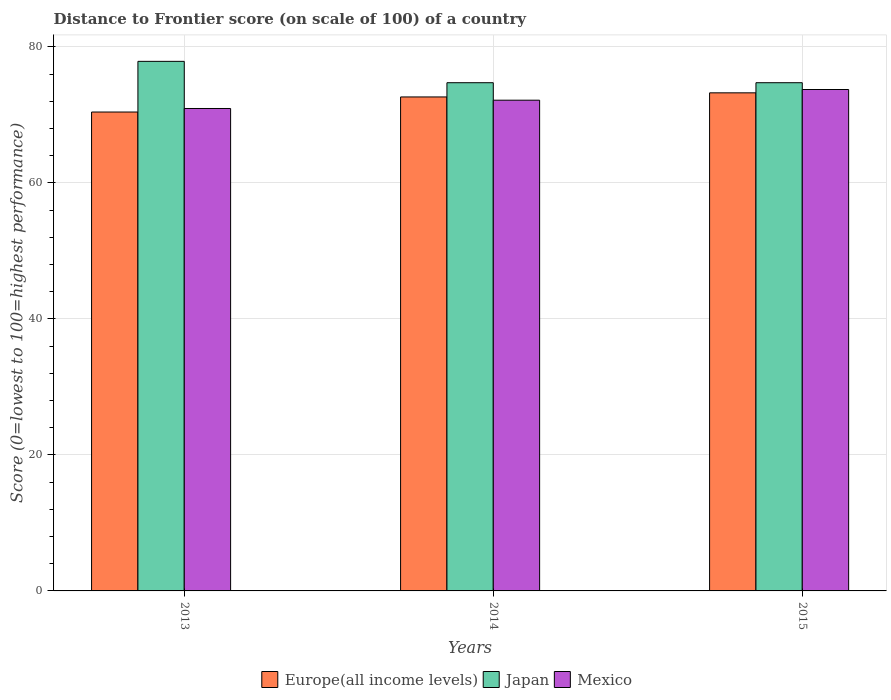How many groups of bars are there?
Keep it short and to the point. 3. Are the number of bars per tick equal to the number of legend labels?
Offer a very short reply. Yes. How many bars are there on the 1st tick from the left?
Your response must be concise. 3. How many bars are there on the 2nd tick from the right?
Make the answer very short. 3. What is the label of the 2nd group of bars from the left?
Offer a very short reply. 2014. In how many cases, is the number of bars for a given year not equal to the number of legend labels?
Offer a terse response. 0. What is the distance to frontier score of in Japan in 2013?
Give a very brief answer. 77.86. Across all years, what is the maximum distance to frontier score of in Europe(all income levels)?
Your answer should be compact. 73.23. Across all years, what is the minimum distance to frontier score of in Japan?
Ensure brevity in your answer.  74.72. In which year was the distance to frontier score of in Europe(all income levels) maximum?
Provide a succinct answer. 2015. In which year was the distance to frontier score of in Europe(all income levels) minimum?
Provide a short and direct response. 2013. What is the total distance to frontier score of in Mexico in the graph?
Give a very brief answer. 216.8. What is the difference between the distance to frontier score of in Mexico in 2015 and the distance to frontier score of in Europe(all income levels) in 2013?
Offer a terse response. 3.31. What is the average distance to frontier score of in Europe(all income levels) per year?
Keep it short and to the point. 72.09. In the year 2014, what is the difference between the distance to frontier score of in Japan and distance to frontier score of in Mexico?
Offer a very short reply. 2.57. In how many years, is the distance to frontier score of in Japan greater than 12?
Your answer should be very brief. 3. What is the ratio of the distance to frontier score of in Europe(all income levels) in 2013 to that in 2014?
Keep it short and to the point. 0.97. Is the distance to frontier score of in Europe(all income levels) in 2013 less than that in 2014?
Provide a short and direct response. Yes. Is the difference between the distance to frontier score of in Japan in 2013 and 2015 greater than the difference between the distance to frontier score of in Mexico in 2013 and 2015?
Keep it short and to the point. Yes. What is the difference between the highest and the second highest distance to frontier score of in Mexico?
Your response must be concise. 1.57. What is the difference between the highest and the lowest distance to frontier score of in Japan?
Your response must be concise. 3.14. Are all the bars in the graph horizontal?
Make the answer very short. No. What is the difference between two consecutive major ticks on the Y-axis?
Make the answer very short. 20. Does the graph contain grids?
Your answer should be very brief. Yes. How many legend labels are there?
Ensure brevity in your answer.  3. How are the legend labels stacked?
Keep it short and to the point. Horizontal. What is the title of the graph?
Keep it short and to the point. Distance to Frontier score (on scale of 100) of a country. What is the label or title of the Y-axis?
Your response must be concise. Score (0=lowest to 100=highest performance). What is the Score (0=lowest to 100=highest performance) of Europe(all income levels) in 2013?
Make the answer very short. 70.41. What is the Score (0=lowest to 100=highest performance) in Japan in 2013?
Provide a short and direct response. 77.86. What is the Score (0=lowest to 100=highest performance) of Mexico in 2013?
Offer a terse response. 70.93. What is the Score (0=lowest to 100=highest performance) of Europe(all income levels) in 2014?
Keep it short and to the point. 72.63. What is the Score (0=lowest to 100=highest performance) in Japan in 2014?
Give a very brief answer. 74.72. What is the Score (0=lowest to 100=highest performance) of Mexico in 2014?
Keep it short and to the point. 72.15. What is the Score (0=lowest to 100=highest performance) of Europe(all income levels) in 2015?
Provide a succinct answer. 73.23. What is the Score (0=lowest to 100=highest performance) of Japan in 2015?
Your answer should be compact. 74.72. What is the Score (0=lowest to 100=highest performance) in Mexico in 2015?
Keep it short and to the point. 73.72. Across all years, what is the maximum Score (0=lowest to 100=highest performance) of Europe(all income levels)?
Offer a very short reply. 73.23. Across all years, what is the maximum Score (0=lowest to 100=highest performance) of Japan?
Provide a short and direct response. 77.86. Across all years, what is the maximum Score (0=lowest to 100=highest performance) of Mexico?
Keep it short and to the point. 73.72. Across all years, what is the minimum Score (0=lowest to 100=highest performance) of Europe(all income levels)?
Keep it short and to the point. 70.41. Across all years, what is the minimum Score (0=lowest to 100=highest performance) of Japan?
Your response must be concise. 74.72. Across all years, what is the minimum Score (0=lowest to 100=highest performance) in Mexico?
Ensure brevity in your answer.  70.93. What is the total Score (0=lowest to 100=highest performance) of Europe(all income levels) in the graph?
Make the answer very short. 216.27. What is the total Score (0=lowest to 100=highest performance) of Japan in the graph?
Keep it short and to the point. 227.3. What is the total Score (0=lowest to 100=highest performance) of Mexico in the graph?
Keep it short and to the point. 216.8. What is the difference between the Score (0=lowest to 100=highest performance) of Europe(all income levels) in 2013 and that in 2014?
Your response must be concise. -2.22. What is the difference between the Score (0=lowest to 100=highest performance) of Japan in 2013 and that in 2014?
Keep it short and to the point. 3.14. What is the difference between the Score (0=lowest to 100=highest performance) of Mexico in 2013 and that in 2014?
Offer a terse response. -1.22. What is the difference between the Score (0=lowest to 100=highest performance) of Europe(all income levels) in 2013 and that in 2015?
Your answer should be compact. -2.82. What is the difference between the Score (0=lowest to 100=highest performance) of Japan in 2013 and that in 2015?
Your answer should be very brief. 3.14. What is the difference between the Score (0=lowest to 100=highest performance) in Mexico in 2013 and that in 2015?
Provide a succinct answer. -2.79. What is the difference between the Score (0=lowest to 100=highest performance) in Europe(all income levels) in 2014 and that in 2015?
Make the answer very short. -0.61. What is the difference between the Score (0=lowest to 100=highest performance) in Mexico in 2014 and that in 2015?
Provide a succinct answer. -1.57. What is the difference between the Score (0=lowest to 100=highest performance) in Europe(all income levels) in 2013 and the Score (0=lowest to 100=highest performance) in Japan in 2014?
Offer a terse response. -4.31. What is the difference between the Score (0=lowest to 100=highest performance) of Europe(all income levels) in 2013 and the Score (0=lowest to 100=highest performance) of Mexico in 2014?
Ensure brevity in your answer.  -1.74. What is the difference between the Score (0=lowest to 100=highest performance) in Japan in 2013 and the Score (0=lowest to 100=highest performance) in Mexico in 2014?
Offer a terse response. 5.71. What is the difference between the Score (0=lowest to 100=highest performance) of Europe(all income levels) in 2013 and the Score (0=lowest to 100=highest performance) of Japan in 2015?
Your answer should be compact. -4.31. What is the difference between the Score (0=lowest to 100=highest performance) in Europe(all income levels) in 2013 and the Score (0=lowest to 100=highest performance) in Mexico in 2015?
Ensure brevity in your answer.  -3.31. What is the difference between the Score (0=lowest to 100=highest performance) in Japan in 2013 and the Score (0=lowest to 100=highest performance) in Mexico in 2015?
Your response must be concise. 4.14. What is the difference between the Score (0=lowest to 100=highest performance) of Europe(all income levels) in 2014 and the Score (0=lowest to 100=highest performance) of Japan in 2015?
Offer a very short reply. -2.09. What is the difference between the Score (0=lowest to 100=highest performance) of Europe(all income levels) in 2014 and the Score (0=lowest to 100=highest performance) of Mexico in 2015?
Your response must be concise. -1.09. What is the average Score (0=lowest to 100=highest performance) in Europe(all income levels) per year?
Your answer should be compact. 72.09. What is the average Score (0=lowest to 100=highest performance) of Japan per year?
Provide a succinct answer. 75.77. What is the average Score (0=lowest to 100=highest performance) of Mexico per year?
Offer a terse response. 72.27. In the year 2013, what is the difference between the Score (0=lowest to 100=highest performance) of Europe(all income levels) and Score (0=lowest to 100=highest performance) of Japan?
Offer a very short reply. -7.45. In the year 2013, what is the difference between the Score (0=lowest to 100=highest performance) in Europe(all income levels) and Score (0=lowest to 100=highest performance) in Mexico?
Provide a short and direct response. -0.52. In the year 2013, what is the difference between the Score (0=lowest to 100=highest performance) in Japan and Score (0=lowest to 100=highest performance) in Mexico?
Provide a short and direct response. 6.93. In the year 2014, what is the difference between the Score (0=lowest to 100=highest performance) in Europe(all income levels) and Score (0=lowest to 100=highest performance) in Japan?
Provide a succinct answer. -2.09. In the year 2014, what is the difference between the Score (0=lowest to 100=highest performance) of Europe(all income levels) and Score (0=lowest to 100=highest performance) of Mexico?
Provide a succinct answer. 0.48. In the year 2014, what is the difference between the Score (0=lowest to 100=highest performance) of Japan and Score (0=lowest to 100=highest performance) of Mexico?
Ensure brevity in your answer.  2.57. In the year 2015, what is the difference between the Score (0=lowest to 100=highest performance) in Europe(all income levels) and Score (0=lowest to 100=highest performance) in Japan?
Offer a very short reply. -1.49. In the year 2015, what is the difference between the Score (0=lowest to 100=highest performance) of Europe(all income levels) and Score (0=lowest to 100=highest performance) of Mexico?
Give a very brief answer. -0.49. In the year 2015, what is the difference between the Score (0=lowest to 100=highest performance) of Japan and Score (0=lowest to 100=highest performance) of Mexico?
Keep it short and to the point. 1. What is the ratio of the Score (0=lowest to 100=highest performance) in Europe(all income levels) in 2013 to that in 2014?
Make the answer very short. 0.97. What is the ratio of the Score (0=lowest to 100=highest performance) of Japan in 2013 to that in 2014?
Your response must be concise. 1.04. What is the ratio of the Score (0=lowest to 100=highest performance) in Mexico in 2013 to that in 2014?
Give a very brief answer. 0.98. What is the ratio of the Score (0=lowest to 100=highest performance) of Europe(all income levels) in 2013 to that in 2015?
Provide a succinct answer. 0.96. What is the ratio of the Score (0=lowest to 100=highest performance) in Japan in 2013 to that in 2015?
Keep it short and to the point. 1.04. What is the ratio of the Score (0=lowest to 100=highest performance) in Mexico in 2013 to that in 2015?
Provide a succinct answer. 0.96. What is the ratio of the Score (0=lowest to 100=highest performance) of Mexico in 2014 to that in 2015?
Offer a very short reply. 0.98. What is the difference between the highest and the second highest Score (0=lowest to 100=highest performance) of Europe(all income levels)?
Provide a succinct answer. 0.61. What is the difference between the highest and the second highest Score (0=lowest to 100=highest performance) in Japan?
Offer a very short reply. 3.14. What is the difference between the highest and the second highest Score (0=lowest to 100=highest performance) of Mexico?
Provide a succinct answer. 1.57. What is the difference between the highest and the lowest Score (0=lowest to 100=highest performance) in Europe(all income levels)?
Keep it short and to the point. 2.82. What is the difference between the highest and the lowest Score (0=lowest to 100=highest performance) of Japan?
Your answer should be very brief. 3.14. What is the difference between the highest and the lowest Score (0=lowest to 100=highest performance) in Mexico?
Offer a very short reply. 2.79. 